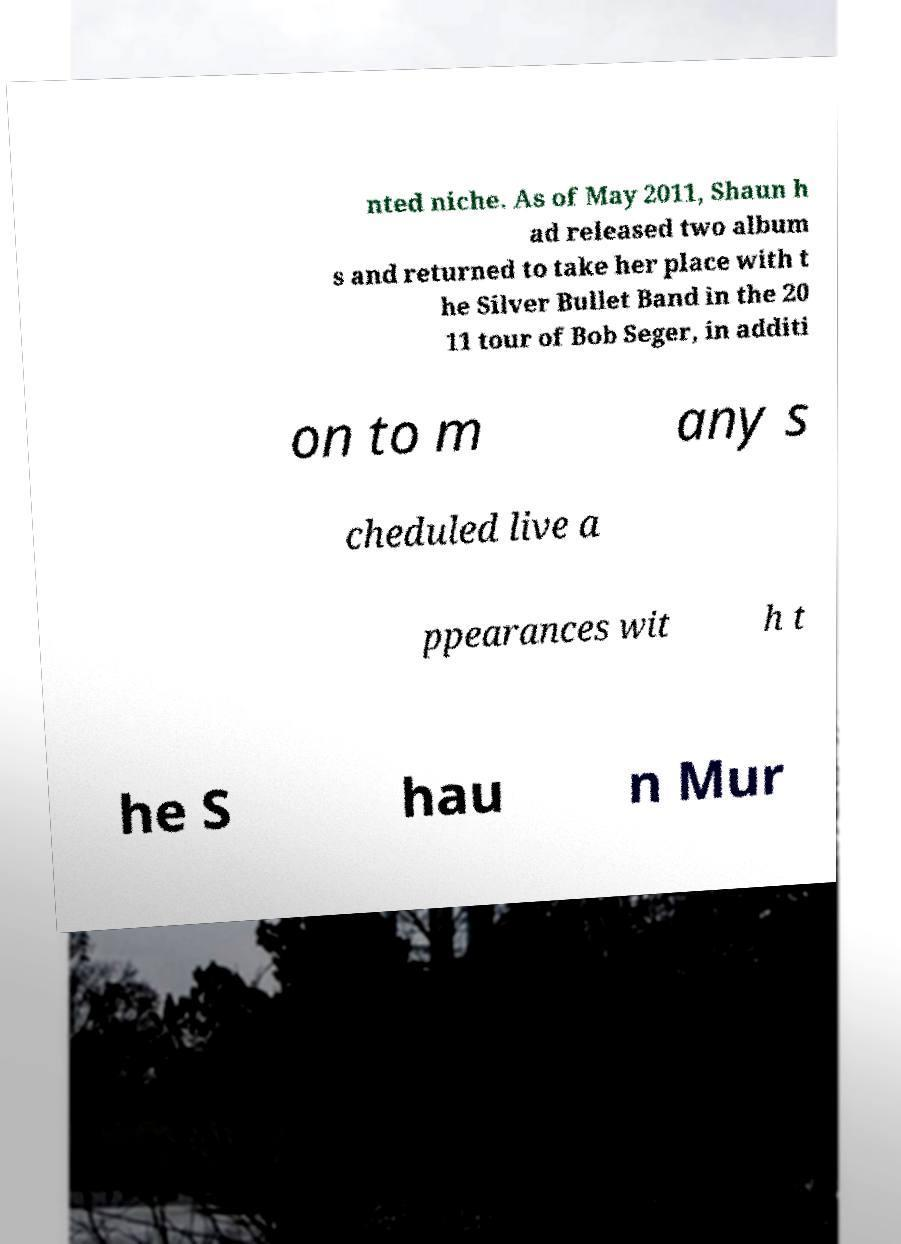There's text embedded in this image that I need extracted. Can you transcribe it verbatim? nted niche. As of May 2011, Shaun h ad released two album s and returned to take her place with t he Silver Bullet Band in the 20 11 tour of Bob Seger, in additi on to m any s cheduled live a ppearances wit h t he S hau n Mur 